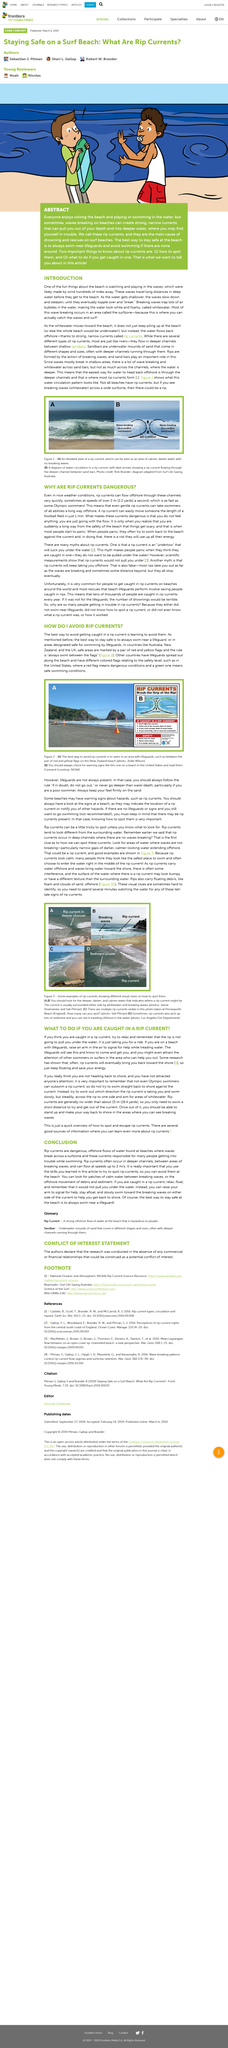Point out several critical features in this image. Most of the wave breaking occurs in the surfzone because this is where surfers can catch the waves and surf. It is advisable to always swim near a lifeguard in order to ensure one's safety while swimming. Yes, rip currents do flow offshore through channels. Rip currents can flow at speeds of over 2 meters per second offshore through channels, making them one of the fastest water currents in the ocean. If you find yourself caught in a rip current, it is important to remain calm and conserve your energy, as it will eventually guide you back to the shore. 